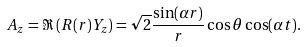Convert formula to latex. <formula><loc_0><loc_0><loc_500><loc_500>A _ { z } = \Re \left ( R ( r ) Y _ { z } \right ) = \sqrt { 2 } \frac { \sin ( \alpha r ) } { r } \cos \theta \cos ( \alpha t ) .</formula> 